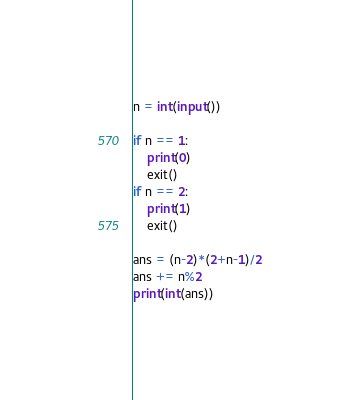Convert code to text. <code><loc_0><loc_0><loc_500><loc_500><_Python_>n = int(input())

if n == 1:
    print(0)
    exit()
if n == 2:
    print(1)
    exit()

ans = (n-2)*(2+n-1)/2
ans += n%2
print(int(ans))</code> 